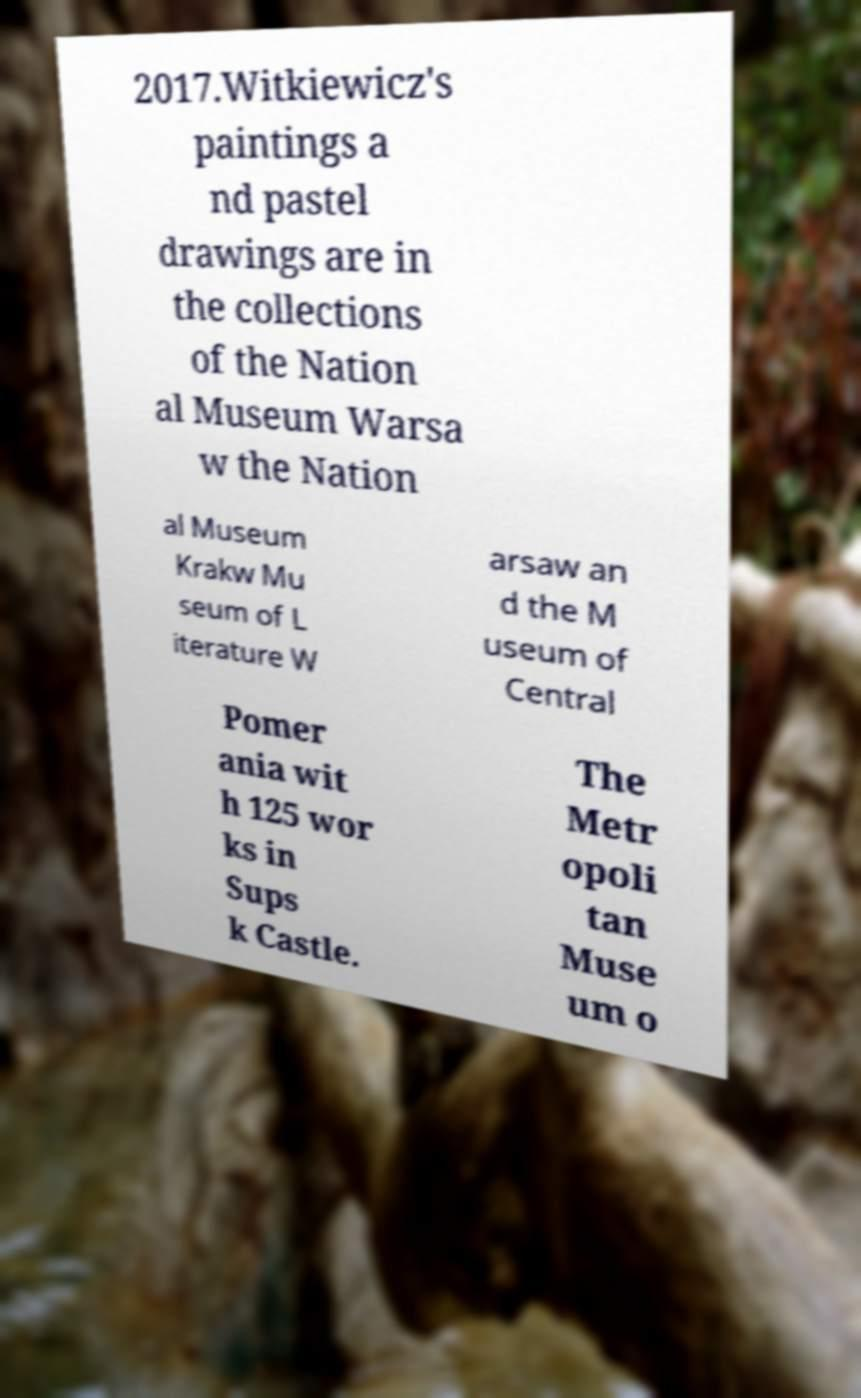What messages or text are displayed in this image? I need them in a readable, typed format. 2017.Witkiewicz's paintings a nd pastel drawings are in the collections of the Nation al Museum Warsa w the Nation al Museum Krakw Mu seum of L iterature W arsaw an d the M useum of Central Pomer ania wit h 125 wor ks in Sups k Castle. The Metr opoli tan Muse um o 